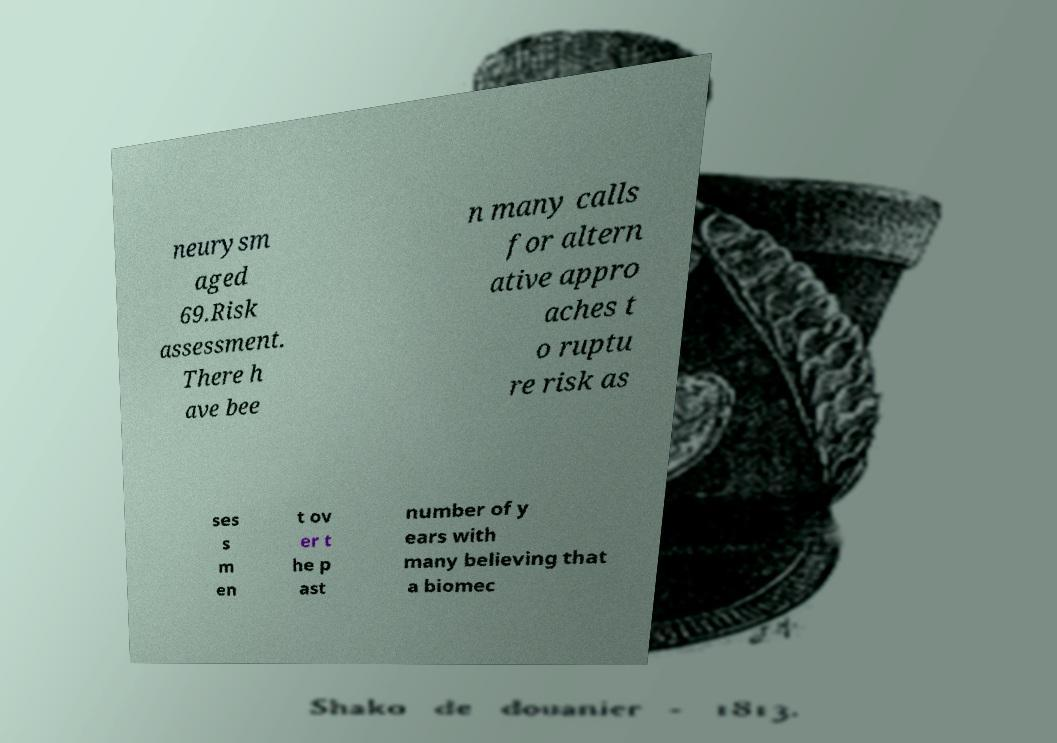Could you extract and type out the text from this image? neurysm aged 69.Risk assessment. There h ave bee n many calls for altern ative appro aches t o ruptu re risk as ses s m en t ov er t he p ast number of y ears with many believing that a biomec 